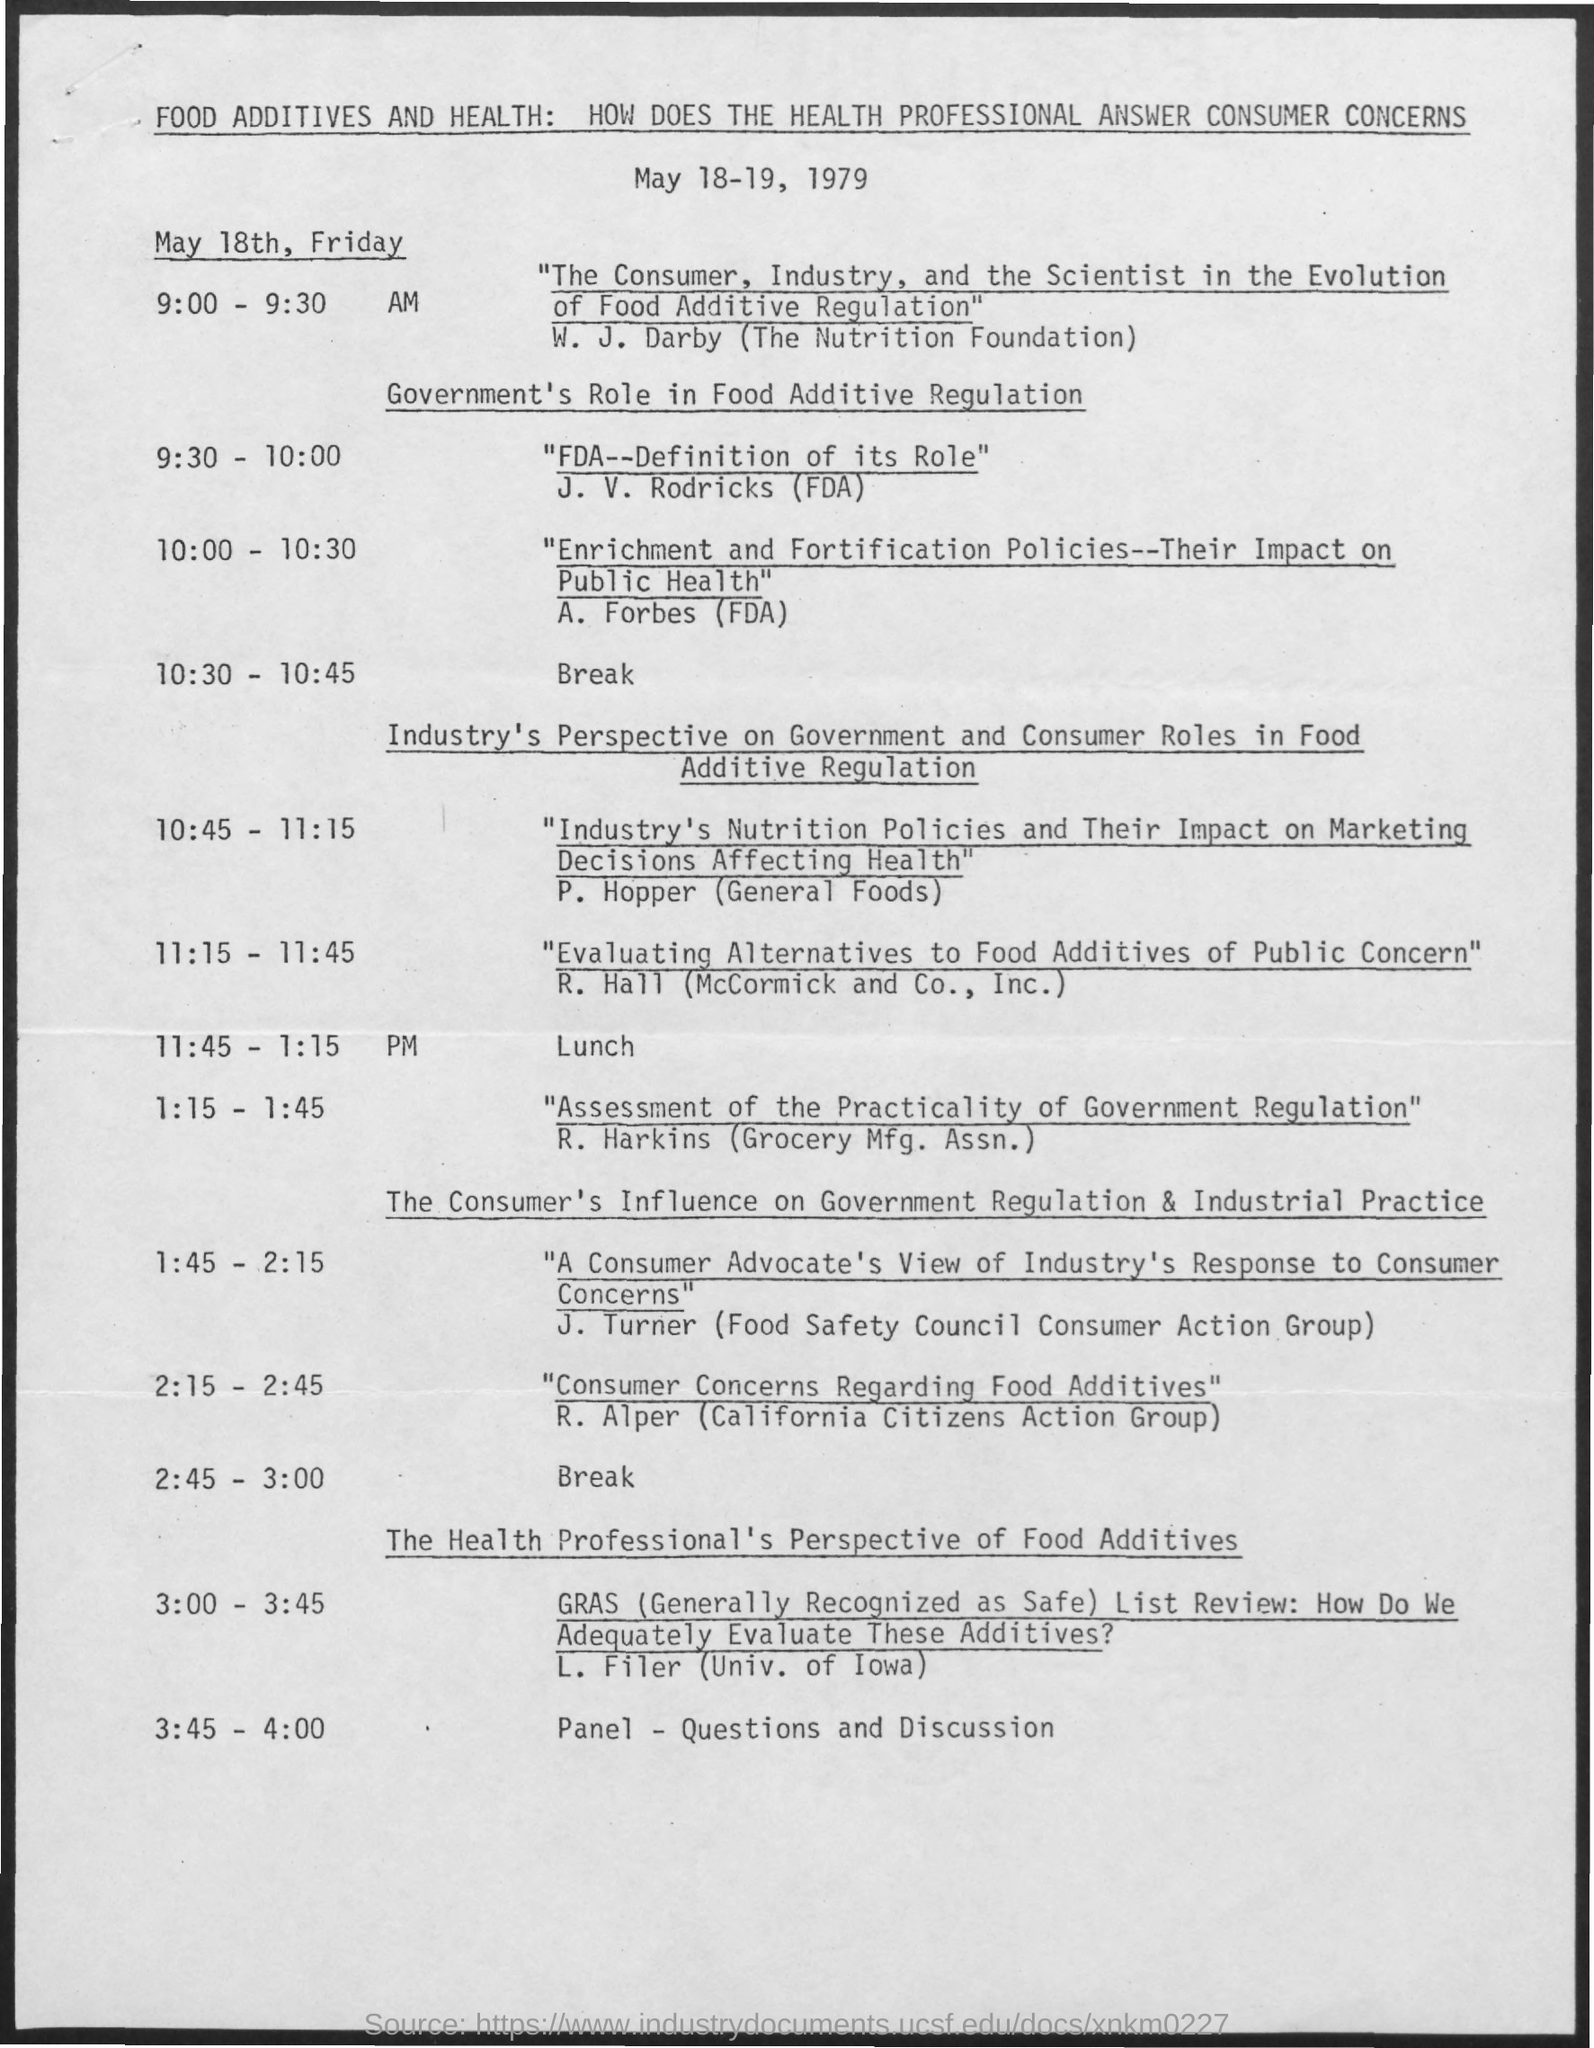What is the lunch time ?
Your answer should be very brief. 11:45 -1:15 Pm. 